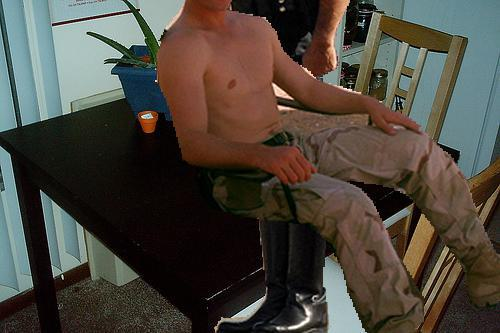Is there a dining table in the image? Yes, there is a dining table present in the image. It appears to be a sturdy, rectangular table that could comfortably seat four people, ideal for family meals or small gatherings. 